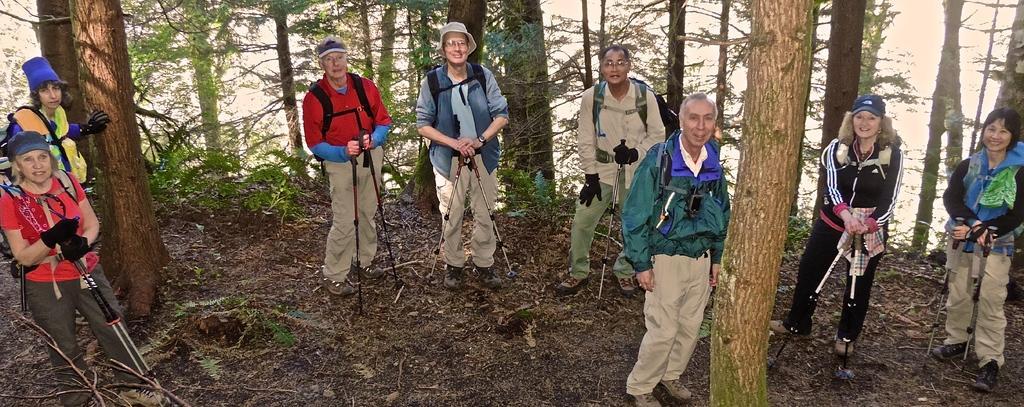How would you summarize this image in a sentence or two? In this image I can see there are many people standing on the ground and there are many trees around. 